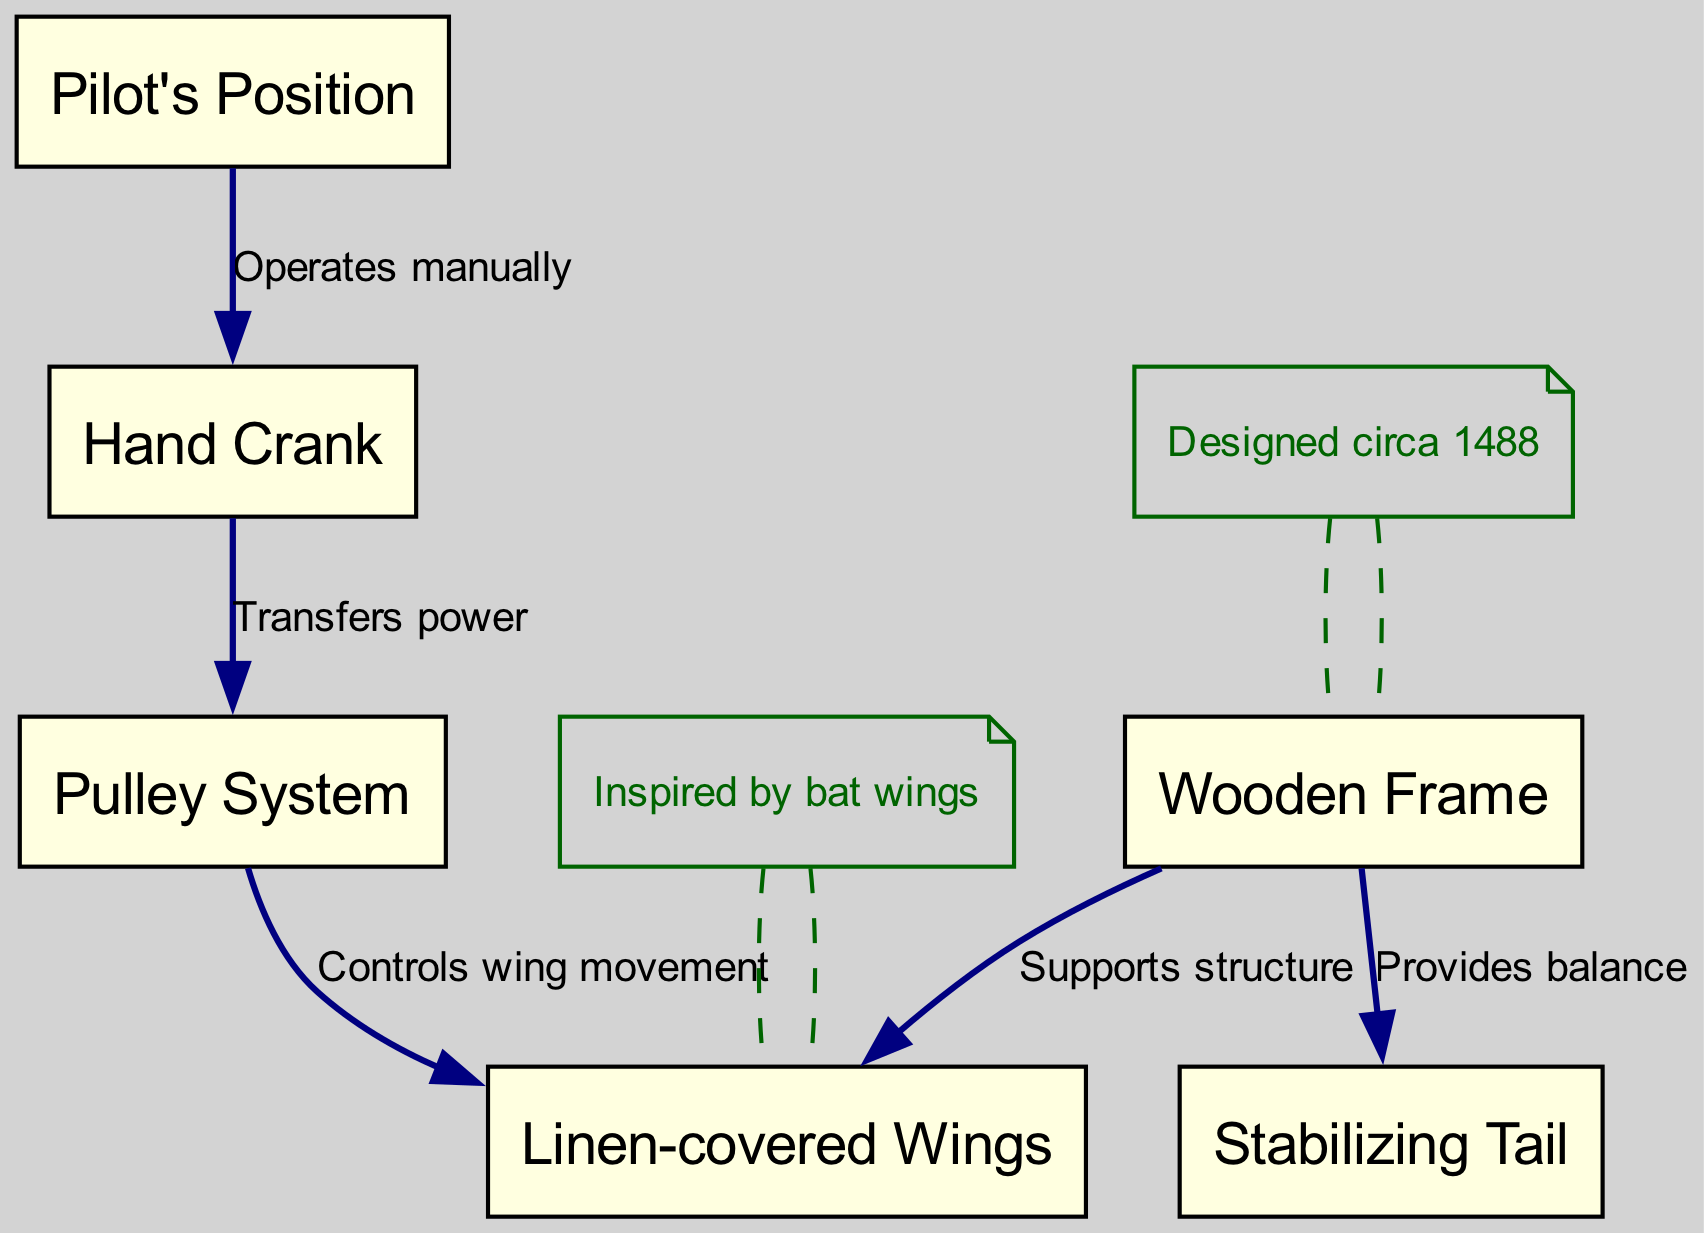What are the types of materials used in the construction of the wings? The wings are specified as "Linen-covered Wings," indicating the primary material is linen, which is a lightweight fabric that aids in flight.
Answer: Linen-covered Wings Who operates the hand crank? The diagram states "Operates manually" from the pilot's position to the crank, meaning the pilot is responsible for manually cranking.
Answer: Pilot How many nodes are there in the diagram? The diagram lists six distinct nodes: Wooden Frame, Linen-covered Wings, Pilot's Position, Hand Crank, Pulley System, and Stabilizing Tail.
Answer: Six What is the purpose of the pulley system? The edges label the function as "Controls wing movement," indicating that the pulley system is designed to manage how the wings move during operation.
Answer: Controls wing movement Which structure provides balance to the flying machine? The edge from the frame to the tail states "Provides balance," identifying the tail as the component responsible for maintaining balance in the design.
Answer: Stabilizing Tail What inspired the design of the wings? Annotations indicate that the design of the wings was "Inspired by bat wings," highlighting the influence of bat anatomy on the flying machine's wing structure.
Answer: Inspired by bat wings What kind of materials are essential for the wooden frame? The annotation notes "Lightweight materials essential," implying that the wooden frame must be constructed from materials that are light to facilitate flight.
Answer: Lightweight materials essential How does the power transfer from the crank to the pulleys? The edge states that the crank "Transfers power" to the pulley system, indicating a direct method of power transmission from one component to another, facilitating wing movement.
Answer: Transfers power When was the design of the flying machine created? The annotations indicate that it was "Designed circa 1488," providing a specific historical context for the machine's creation.
Answer: Designed circa 1488 